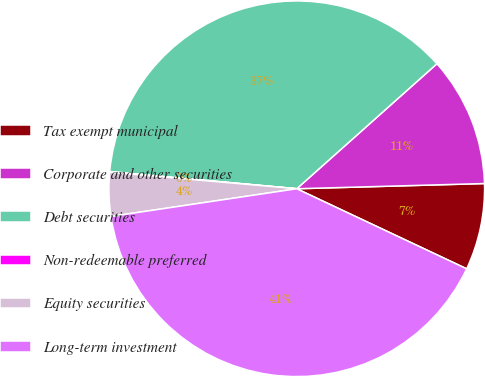<chart> <loc_0><loc_0><loc_500><loc_500><pie_chart><fcel>Tax exempt municipal<fcel>Corporate and other securities<fcel>Debt securities<fcel>Non-redeemable preferred<fcel>Equity securities<fcel>Long-term investment<nl><fcel>7.45%<fcel>11.15%<fcel>36.95%<fcel>0.06%<fcel>3.76%<fcel>40.64%<nl></chart> 